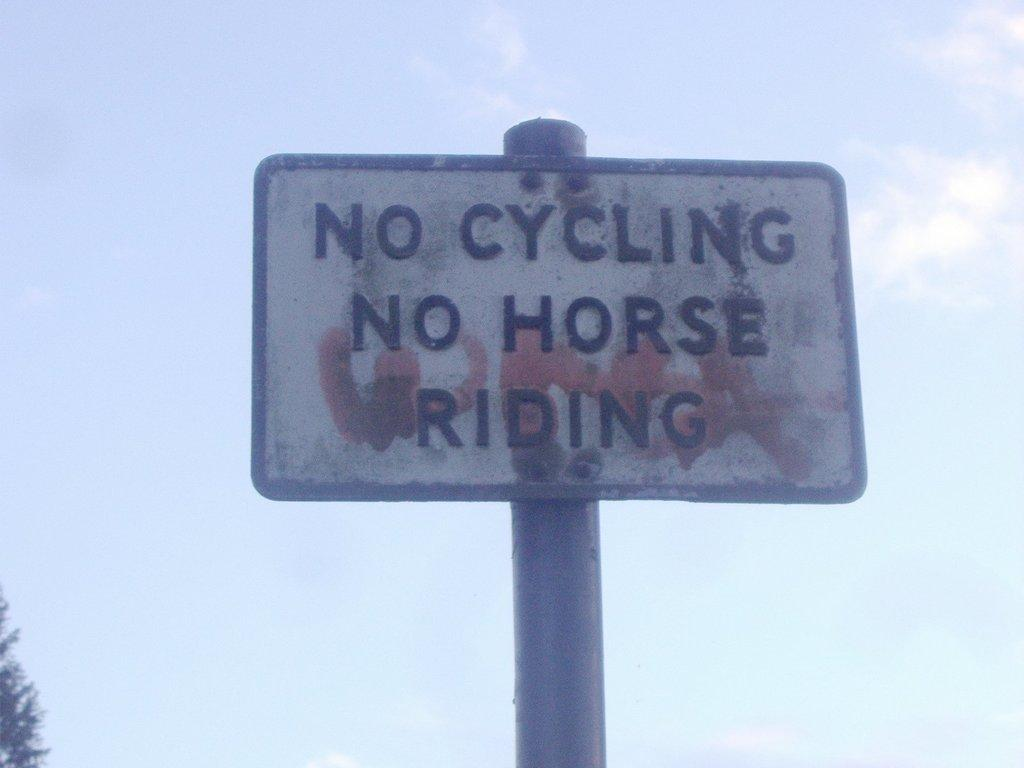<image>
Create a compact narrative representing the image presented. A sign that says no cycling no horse riding. 